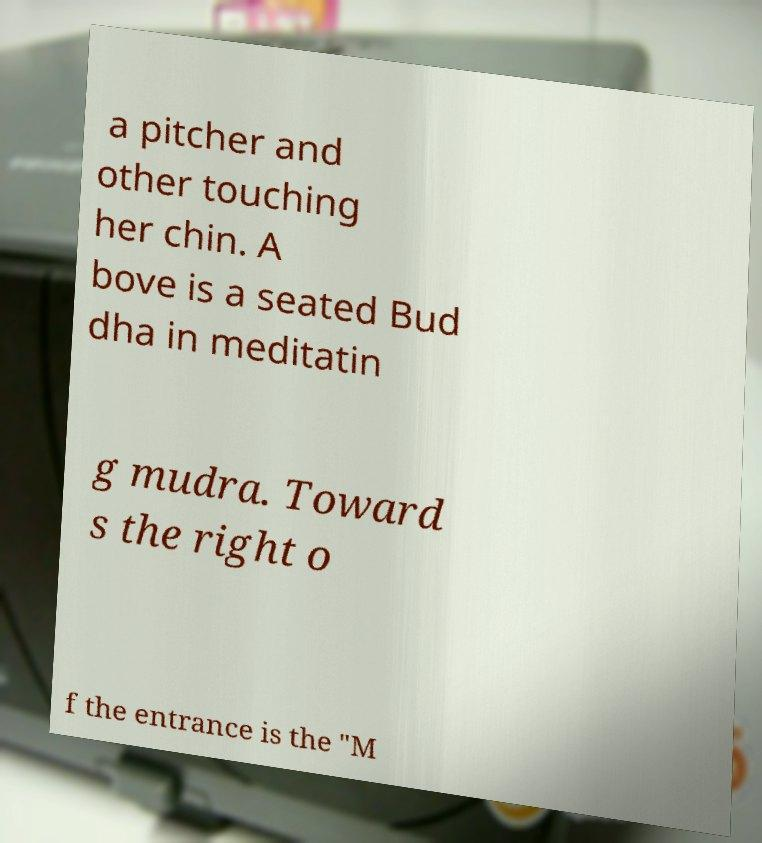Please identify and transcribe the text found in this image. a pitcher and other touching her chin. A bove is a seated Bud dha in meditatin g mudra. Toward s the right o f the entrance is the "M 